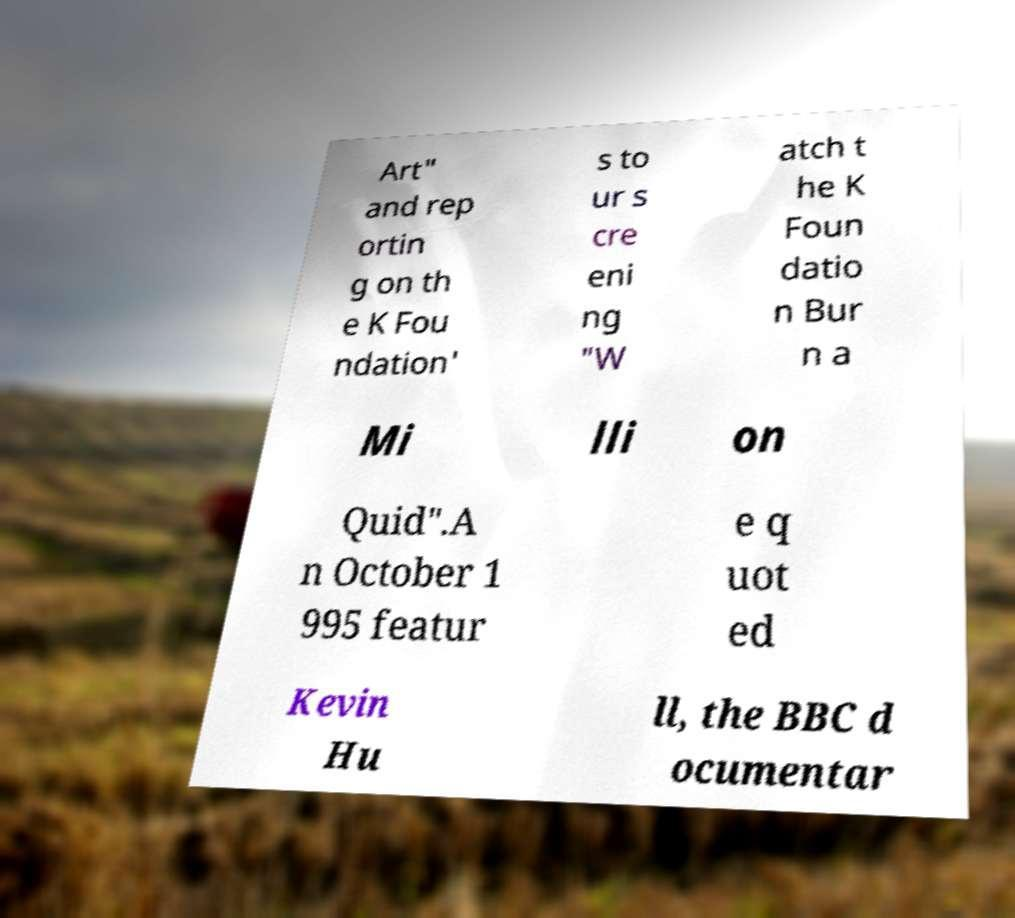Could you extract and type out the text from this image? Art" and rep ortin g on th e K Fou ndation' s to ur s cre eni ng "W atch t he K Foun datio n Bur n a Mi lli on Quid".A n October 1 995 featur e q uot ed Kevin Hu ll, the BBC d ocumentar 